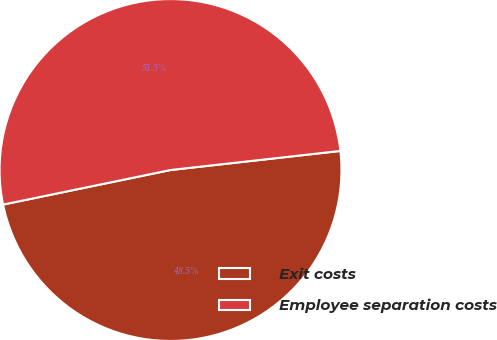Convert chart. <chart><loc_0><loc_0><loc_500><loc_500><pie_chart><fcel>Exit costs<fcel>Employee separation costs<nl><fcel>48.54%<fcel>51.46%<nl></chart> 